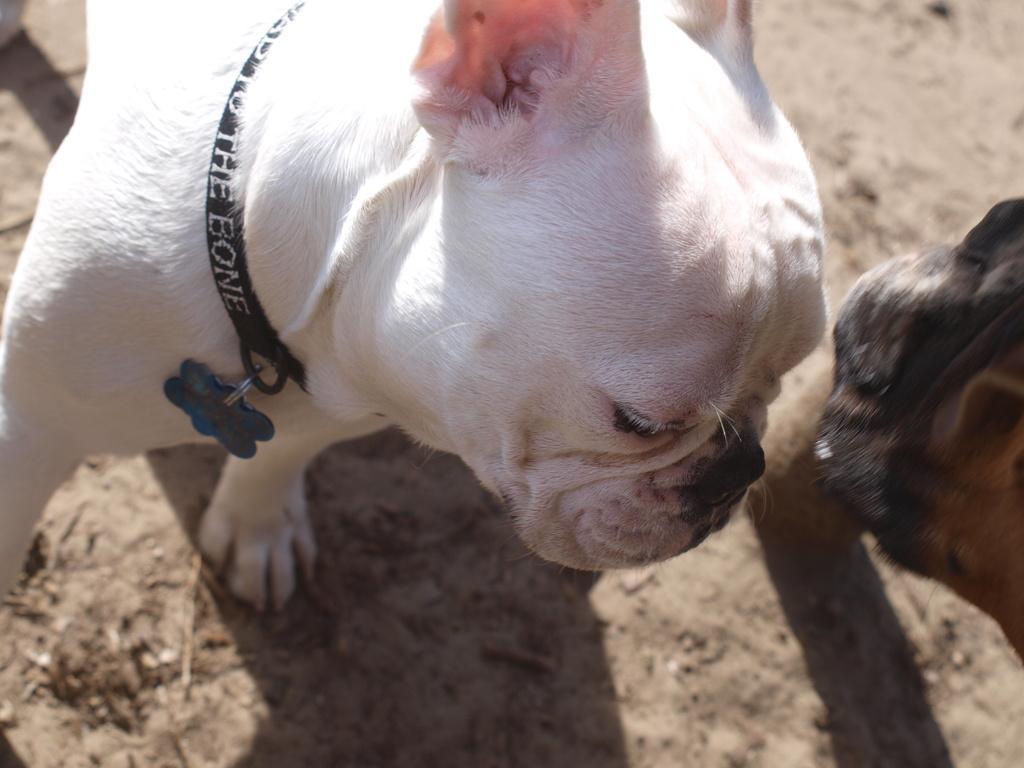Can you describe this image briefly? In this picture we can see animals on the ground. There is some text on a belt visible on the white animal. 